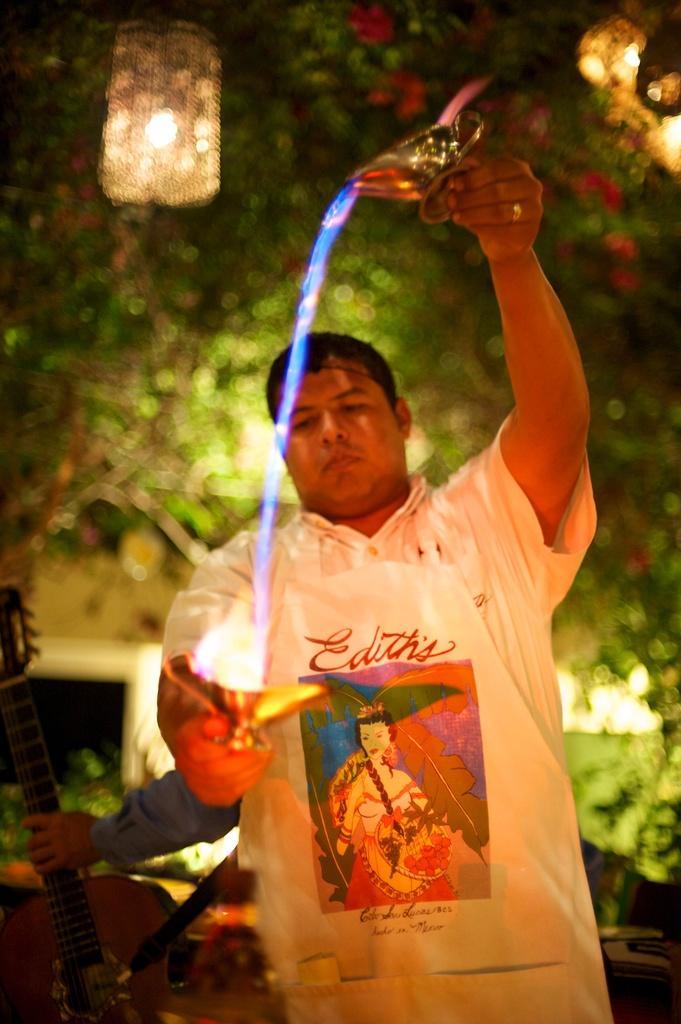In one or two sentences, can you explain what this image depicts? In this image we can see a person holding objects. Behind the person we can see a hand of a person holding an object and a tree. At the top we have two lights. 